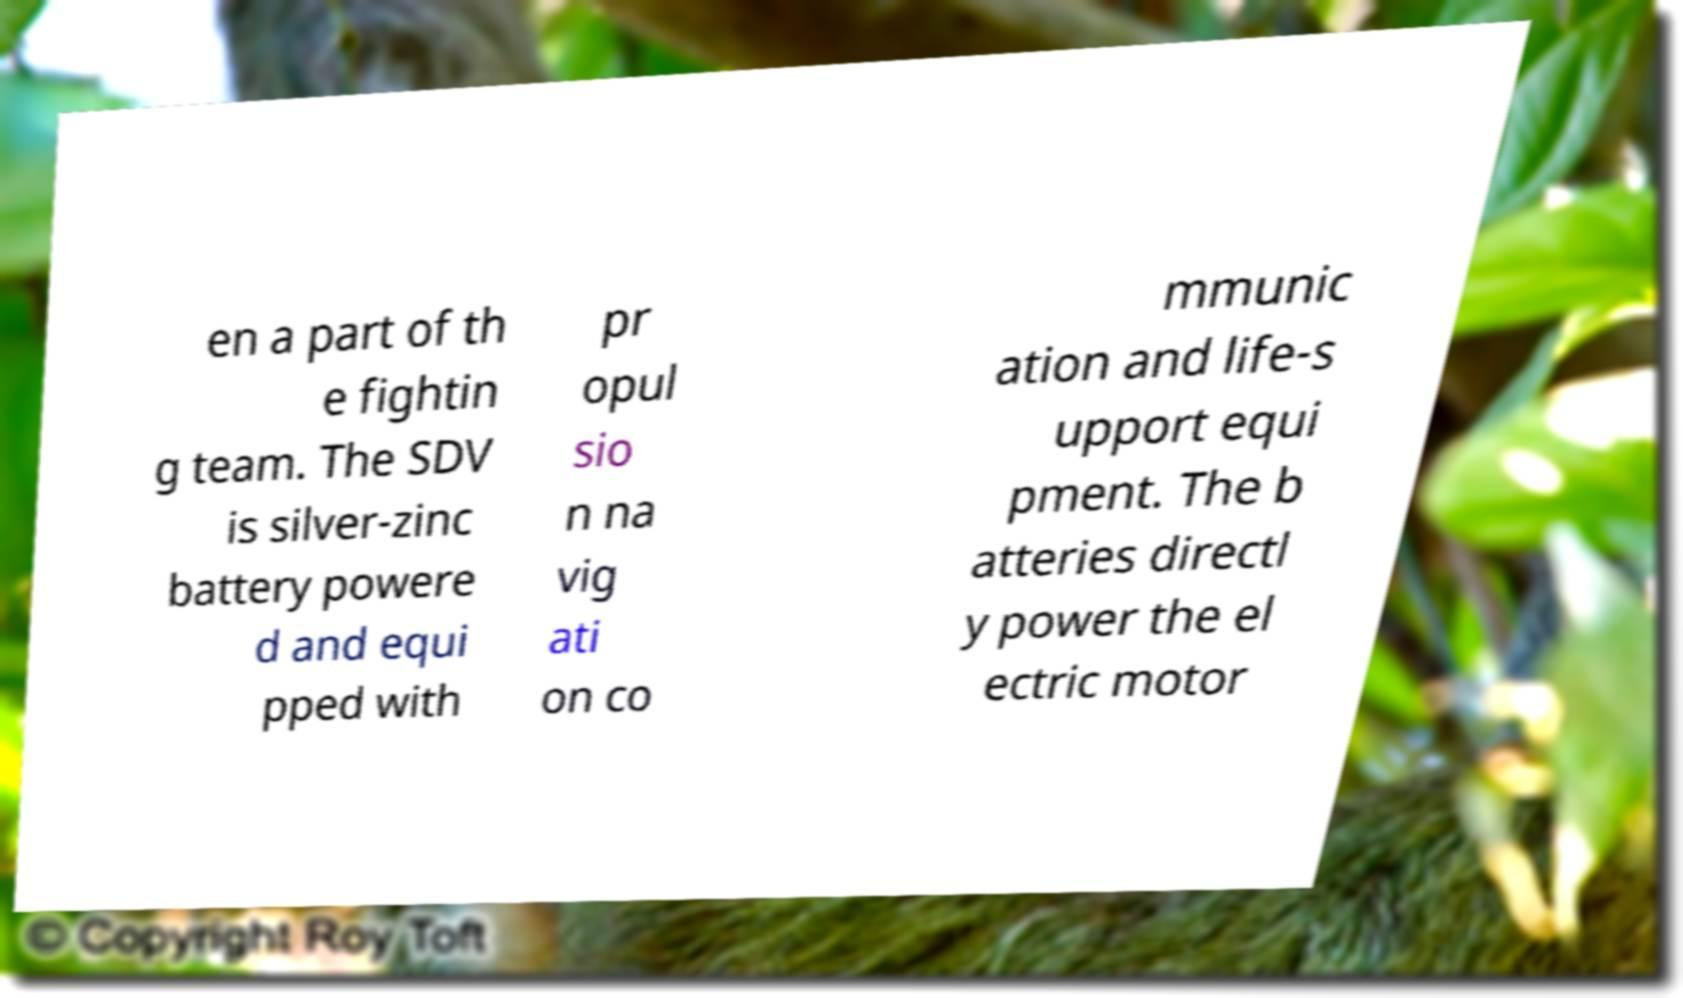Could you assist in decoding the text presented in this image and type it out clearly? en a part of th e fightin g team. The SDV is silver-zinc battery powere d and equi pped with pr opul sio n na vig ati on co mmunic ation and life-s upport equi pment. The b atteries directl y power the el ectric motor 